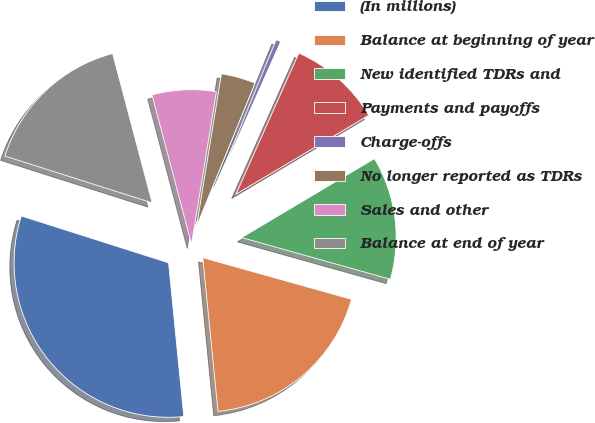Convert chart to OTSL. <chart><loc_0><loc_0><loc_500><loc_500><pie_chart><fcel>(In millions)<fcel>Balance at beginning of year<fcel>New identified TDRs and<fcel>Payments and payoffs<fcel>Charge-offs<fcel>No longer reported as TDRs<fcel>Sales and other<fcel>Balance at end of year<nl><fcel>31.47%<fcel>19.08%<fcel>12.89%<fcel>9.79%<fcel>0.5%<fcel>3.6%<fcel>6.69%<fcel>15.98%<nl></chart> 